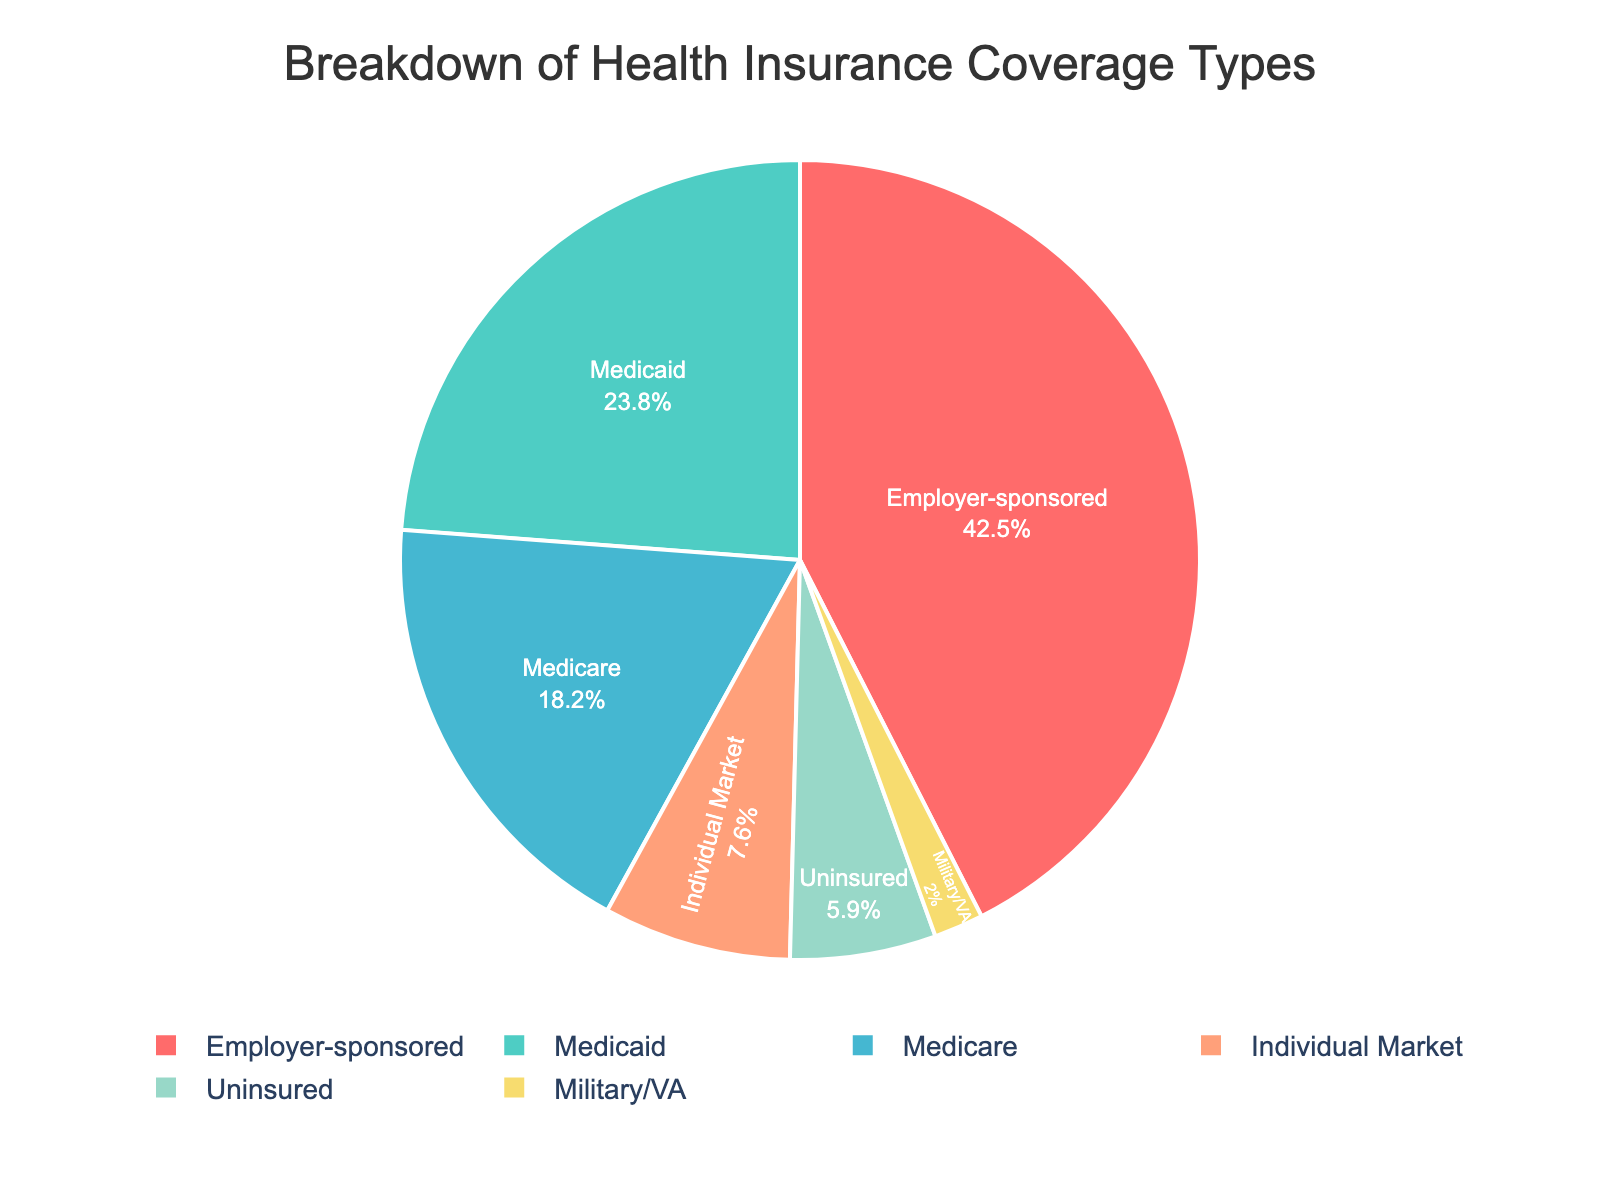What is the largest segment in the pie chart? The largest segment in the pie chart represents the category with the highest percentage. By looking at the chart, we can see that the "Employer-sponsored" segment is the largest.
Answer: Employer-sponsored Which category has the smallest representation in the community? By examining the pie chart, the smallest segment can be identified. In this case, the segment for "Military/VA" is the smallest.
Answer: Military/VA What is the combined percentage of people covered by Medicare and Medicaid? To find the combined percentage, add the percentages of Medicare and Medicaid together: 18.2% + 23.8%. This results in 42.0%.
Answer: 42.0% How does the percentage of uninsured people compare to those with individual market insurance? Compare the percentages: The uninsured group has 5.9%, while the individual market insurance group has 7.6%. The uninsured percentage is less than the individual market percentage.
Answer: Less What is the total percentage of the population that is covered by either Medicaid or Employer-sponsored insurance? To find the total percentage, sum the percentages of Medicaid and Employer-sponsored insurance: 23.8% + 42.5%. This results in 66.3%.
Answer: 66.3% Is the percentage of people with Medicare coverage greater than, less than, or equal to those with individual market insurance? Compare the two percentages: Medicare has 18.2% and individual market insurance has 7.6%. Medicare is greater.
Answer: Greater What is the difference in percentage between the Employer-sponsored and the Uninsured categories? To find the difference, subtract the percentage of Uninsured from that of Employer-sponsored insurance: 42.5% - 5.9%. This results in 36.6%.
Answer: 36.6% Which categories combined represent less than 10% of the community's health insurance coverage? Identify segments with less than 10% individually: "Individual Market" (7.6%) and "Military/VA" (2.0%). Together they represent 9.6%.
Answer: Individual Market and Military/VA What color represents the Medicaid coverage segment in the pie chart? By identifying the color assigned to each segment, the "Medicaid" segment is represented using the color light green.
Answer: Light green How many categories have a coverage percentage higher than 20%? By examining the chart, the categories with more than 20% each are "Employer-sponsored" (42.5%) and "Medicaid" (23.8%). This results in 2 categories.
Answer: 2 